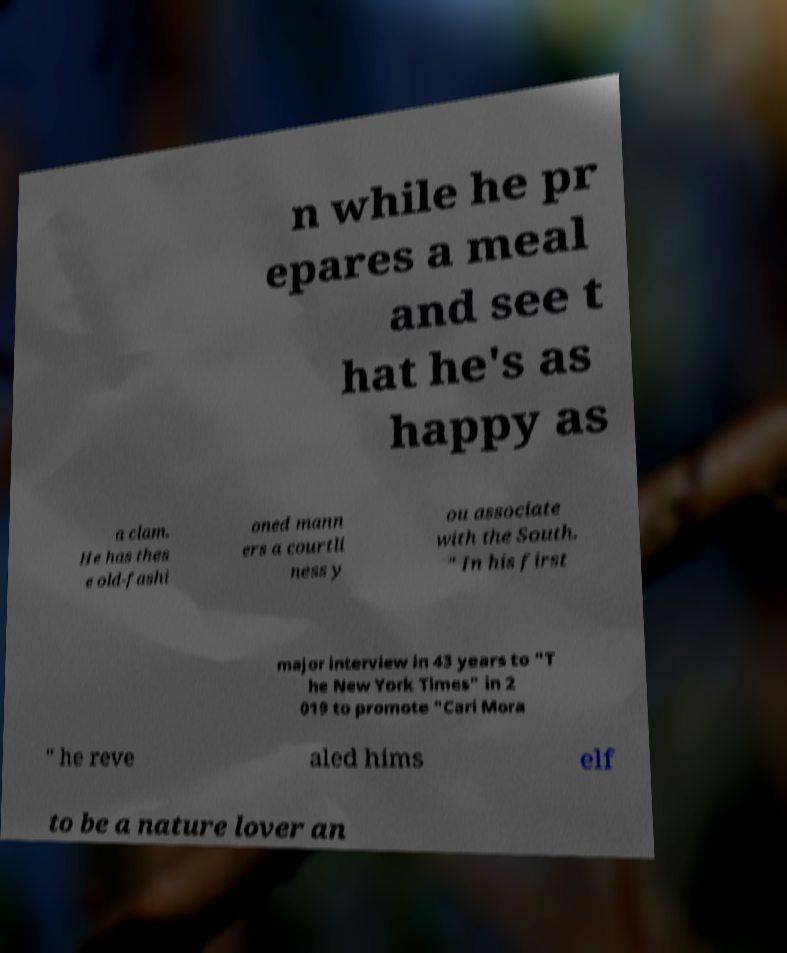There's text embedded in this image that I need extracted. Can you transcribe it verbatim? n while he pr epares a meal and see t hat he's as happy as a clam. He has thes e old-fashi oned mann ers a courtli ness y ou associate with the South. " In his first major interview in 43 years to "T he New York Times" in 2 019 to promote "Cari Mora " he reve aled hims elf to be a nature lover an 